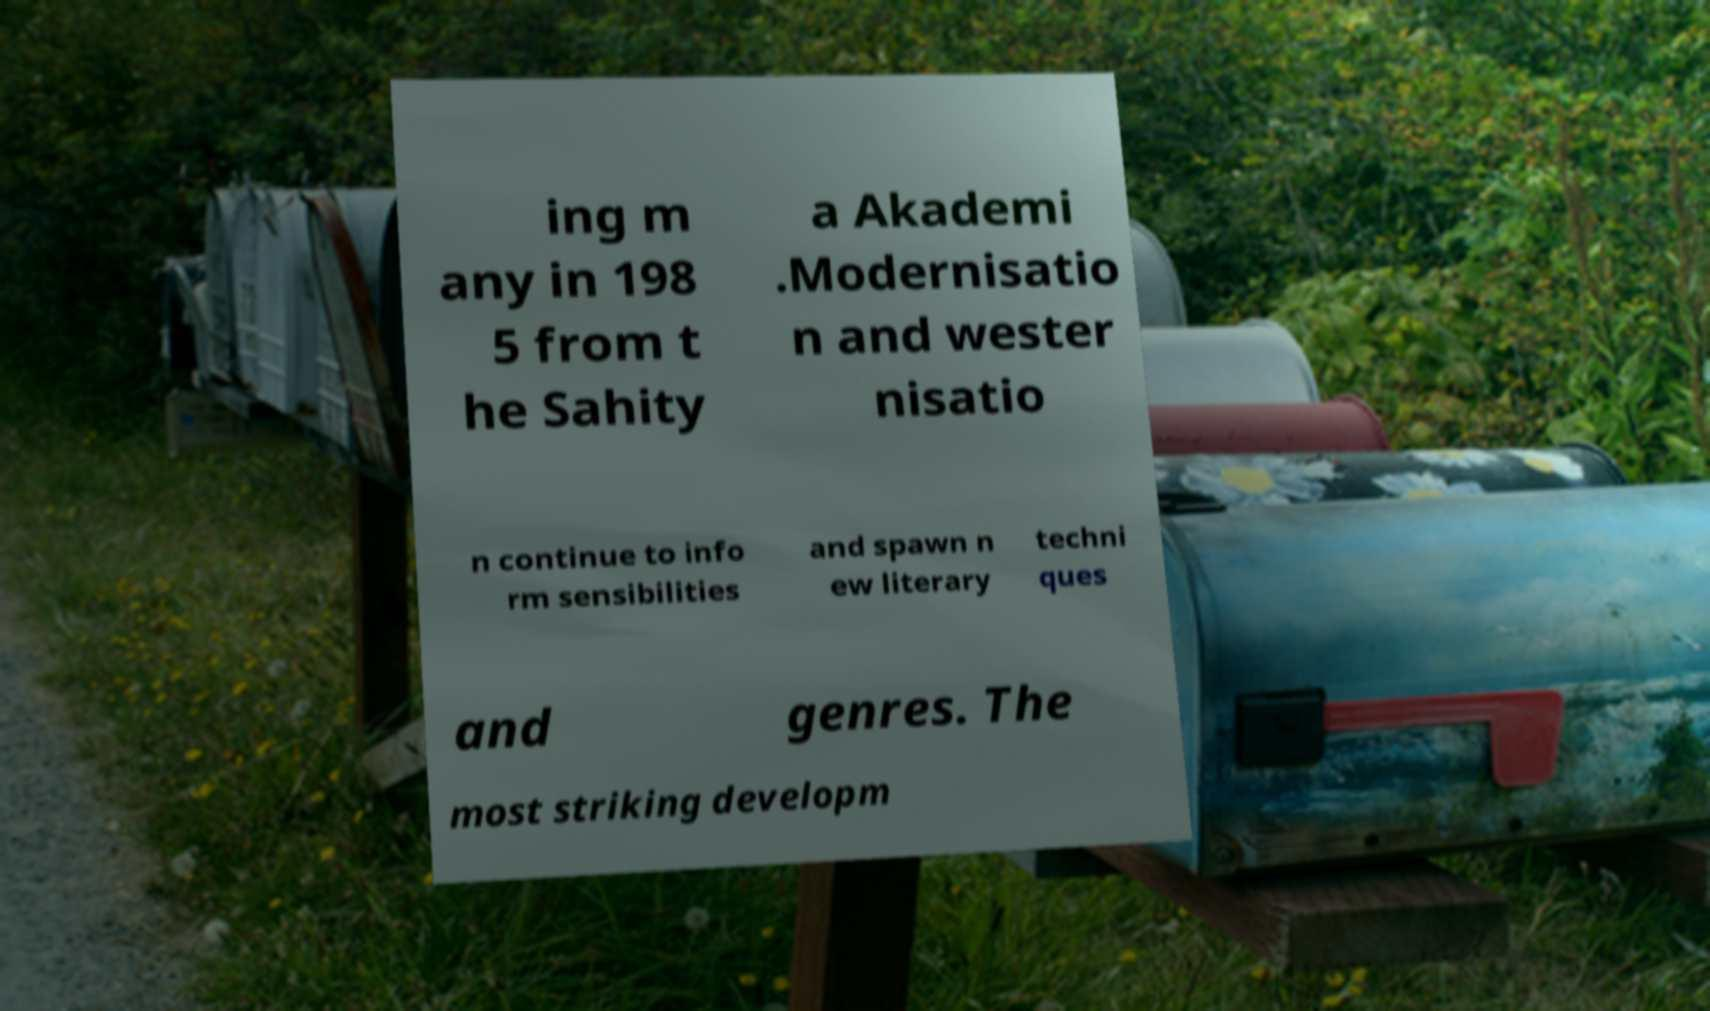Could you extract and type out the text from this image? ing m any in 198 5 from t he Sahity a Akademi .Modernisatio n and wester nisatio n continue to info rm sensibilities and spawn n ew literary techni ques and genres. The most striking developm 